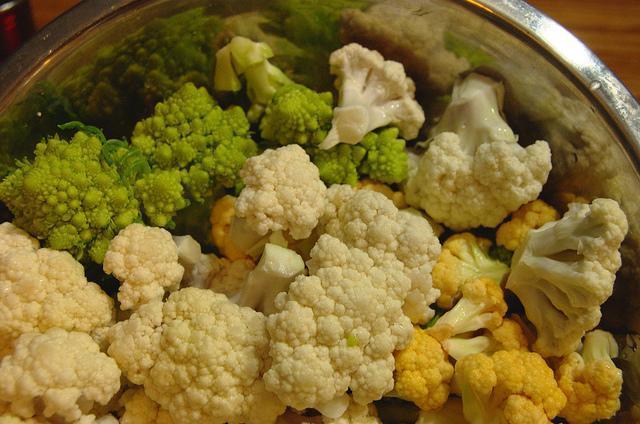How many broccolis are in the picture?
Give a very brief answer. 4. How many people will the pizza likely serve?
Give a very brief answer. 0. 